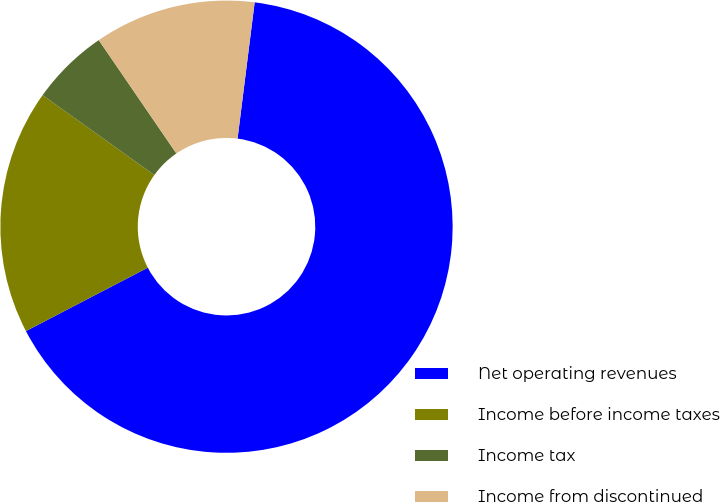Convert chart. <chart><loc_0><loc_0><loc_500><loc_500><pie_chart><fcel>Net operating revenues<fcel>Income before income taxes<fcel>Income tax<fcel>Income from discontinued<nl><fcel>65.37%<fcel>17.52%<fcel>5.56%<fcel>11.54%<nl></chart> 